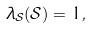Convert formula to latex. <formula><loc_0><loc_0><loc_500><loc_500>\lambda _ { \mathcal { S } } ( \mathcal { S } ) = 1 ,</formula> 